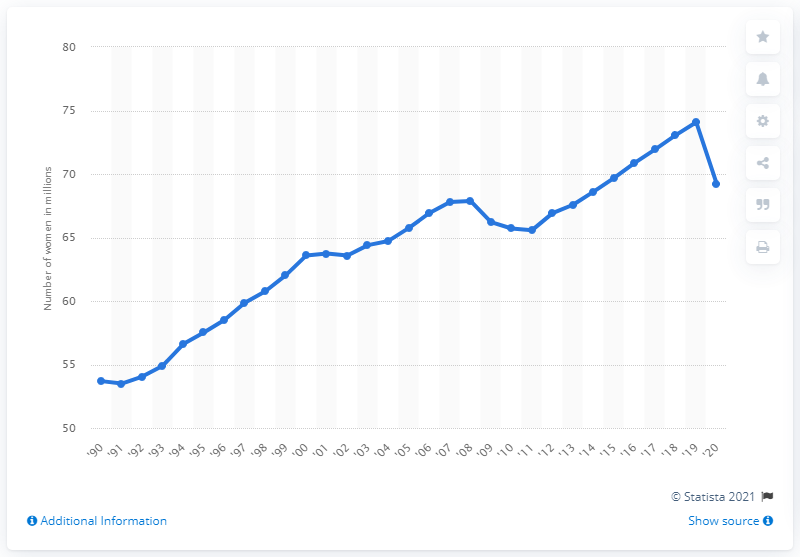Identify some key points in this picture. In 2020, approximately 69.23% of women in the United States were employed. 